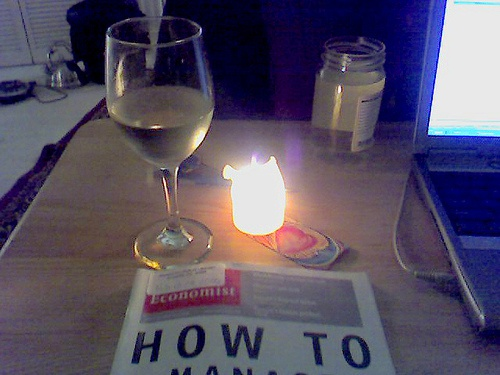Describe the objects in this image and their specific colors. I can see dining table in gray, purple, and navy tones, book in gray, black, and navy tones, laptop in gray, navy, lightgray, and darkblue tones, wine glass in gray, black, and navy tones, and bottle in gray, navy, and purple tones in this image. 